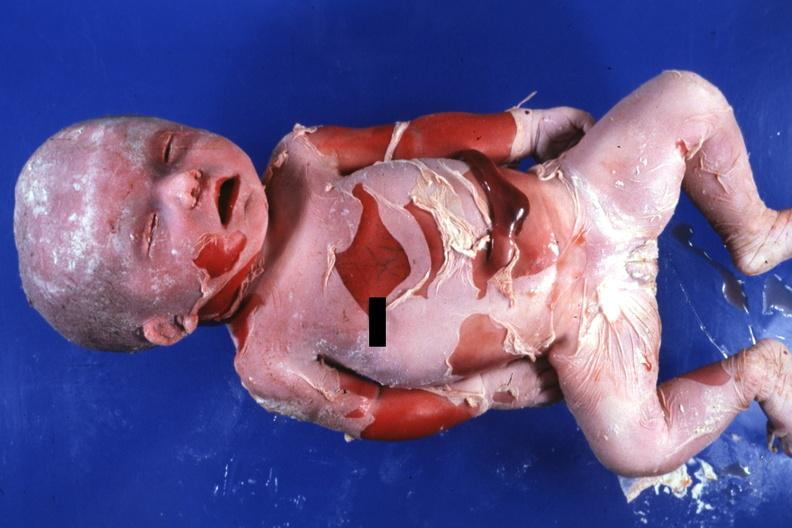s natural color advanced typical?
Answer the question using a single word or phrase. Yes 